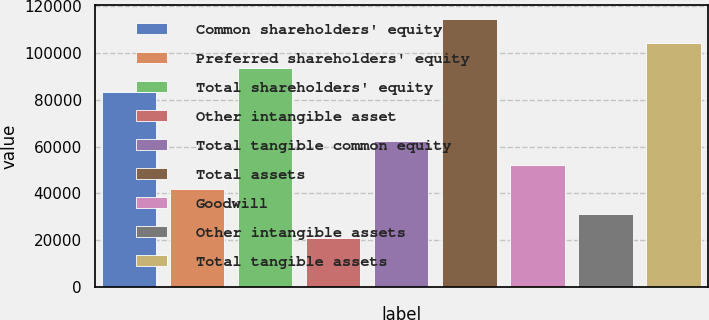<chart> <loc_0><loc_0><loc_500><loc_500><bar_chart><fcel>Common shareholders' equity<fcel>Preferred shareholders' equity<fcel>Total shareholders' equity<fcel>Other intangible asset<fcel>Total tangible common equity<fcel>Total assets<fcel>Goodwill<fcel>Other intangible assets<fcel>Total tangible assets<nl><fcel>83349.5<fcel>41678.4<fcel>93767.3<fcel>20842.9<fcel>62514<fcel>114603<fcel>52096.2<fcel>31260.7<fcel>104185<nl></chart> 